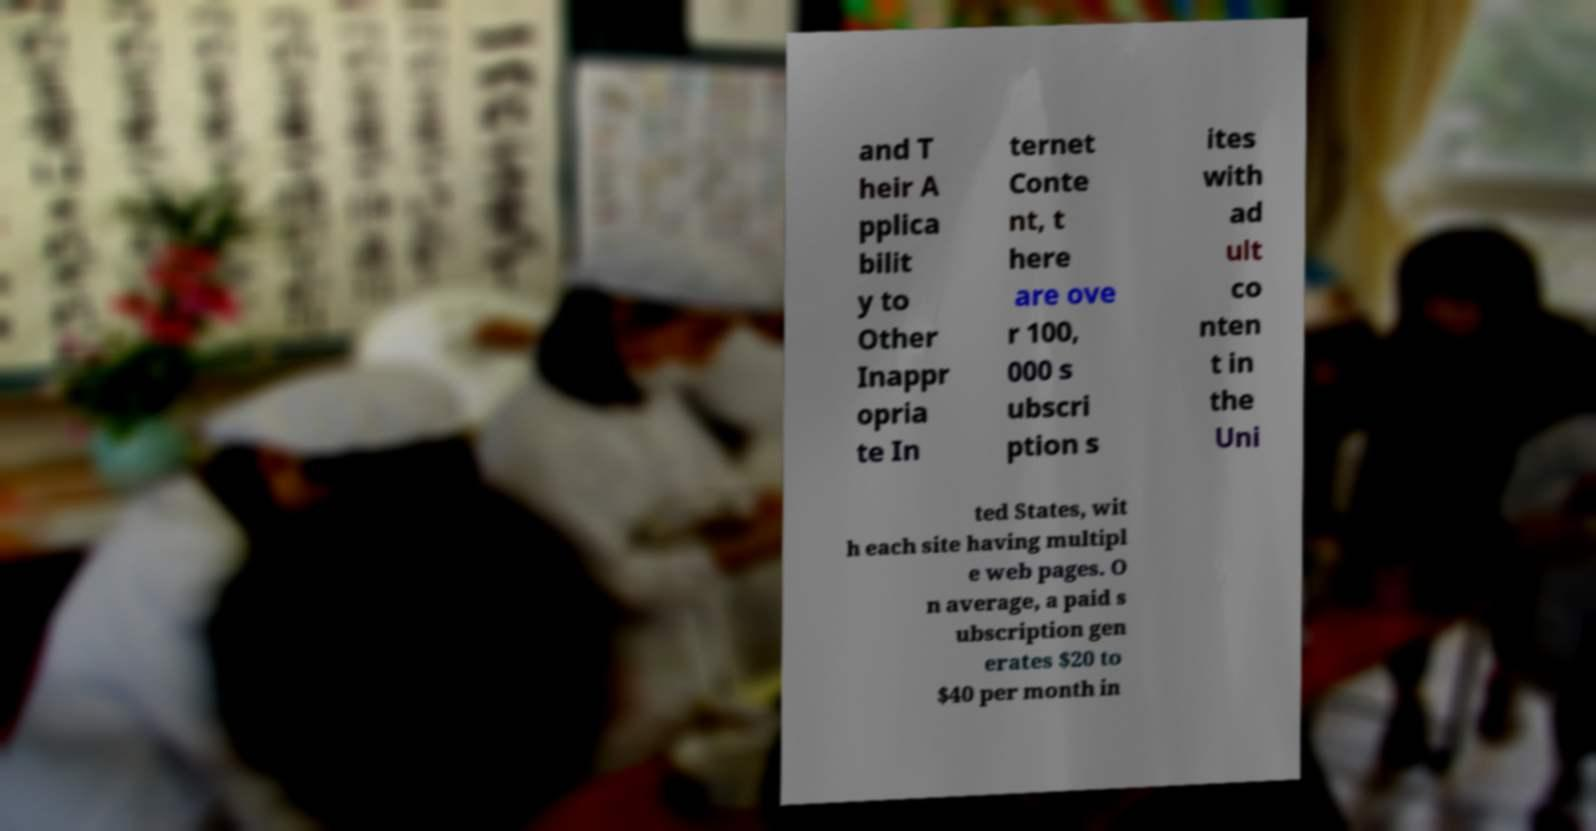Please identify and transcribe the text found in this image. and T heir A pplica bilit y to Other Inappr opria te In ternet Conte nt, t here are ove r 100, 000 s ubscri ption s ites with ad ult co nten t in the Uni ted States, wit h each site having multipl e web pages. O n average, a paid s ubscription gen erates $20 to $40 per month in 